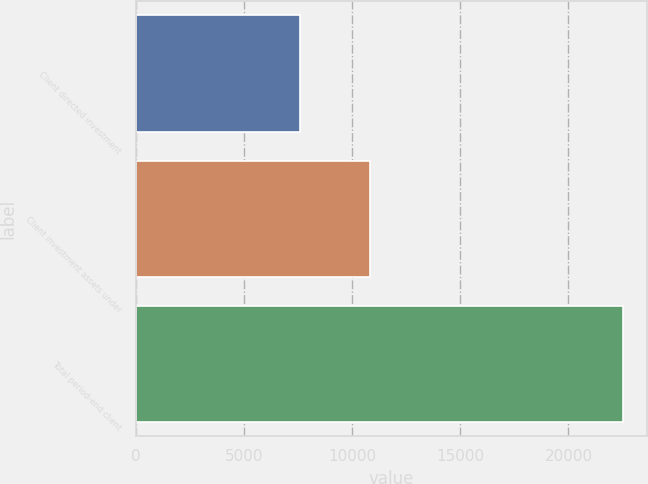<chart> <loc_0><loc_0><loc_500><loc_500><bar_chart><fcel>Client directed investment<fcel>Client investment assets under<fcel>Total period-end client<nl><fcel>7604<fcel>10824<fcel>22513<nl></chart> 